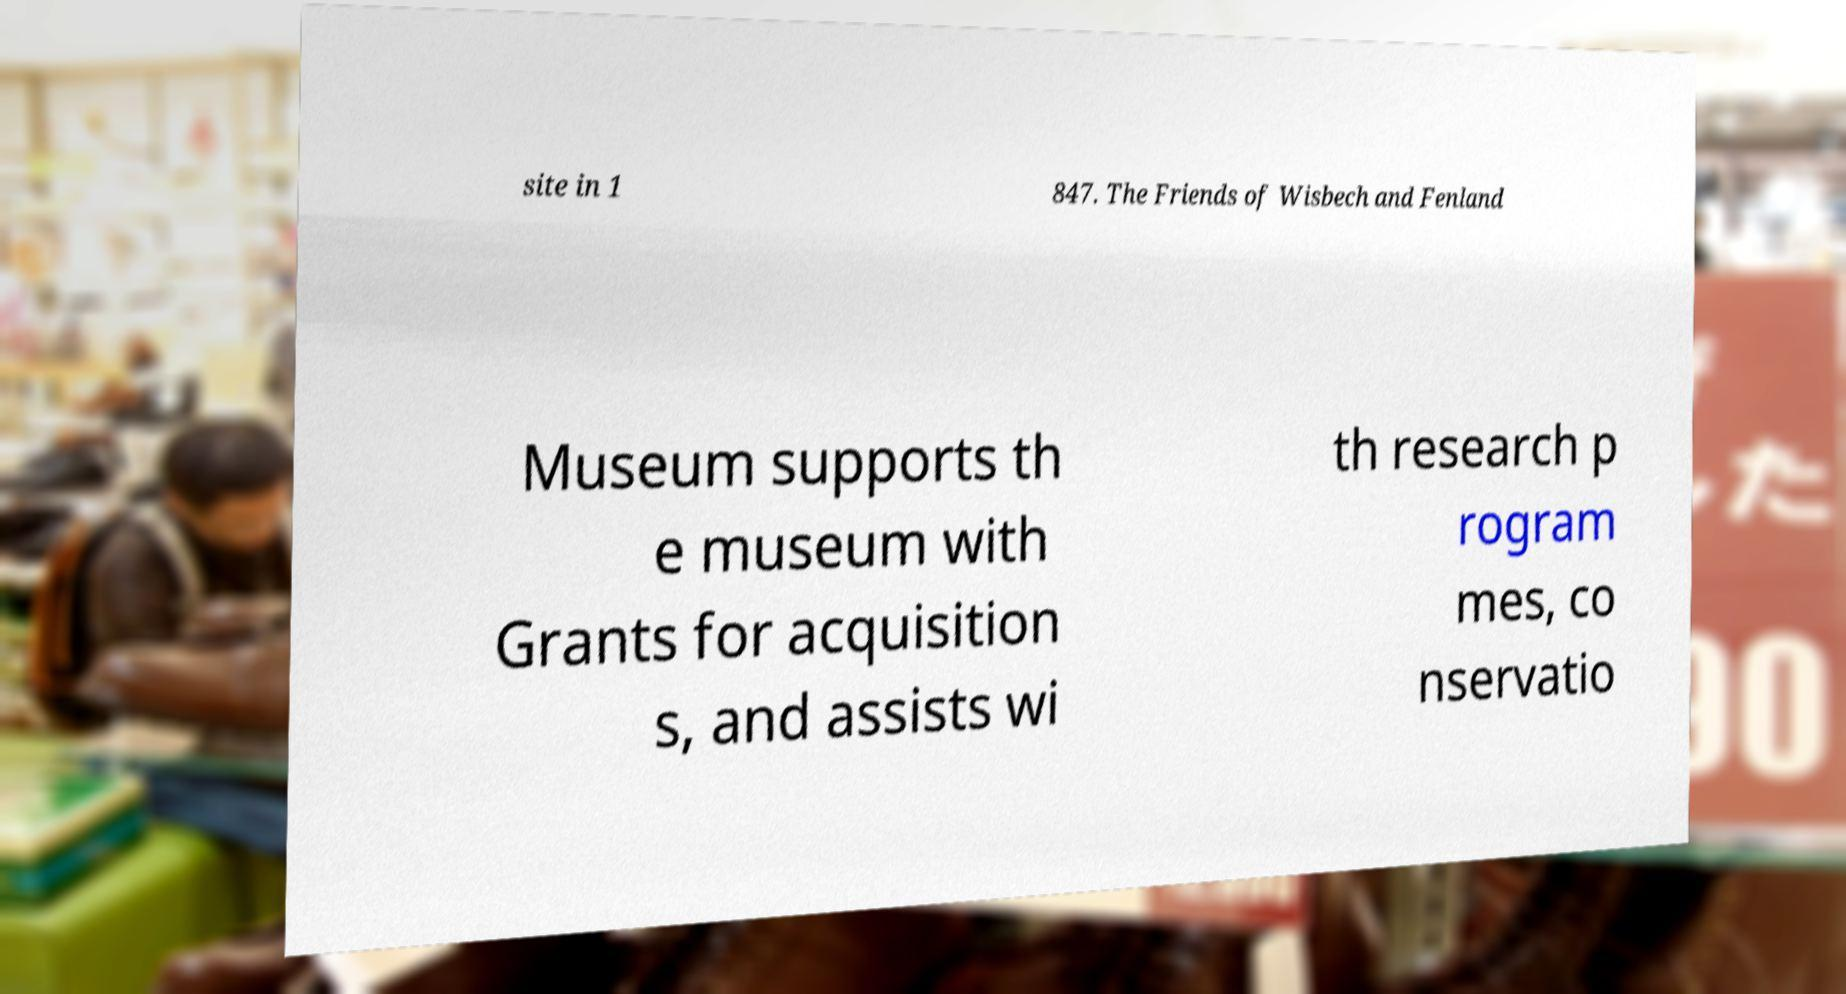Could you extract and type out the text from this image? site in 1 847. The Friends of Wisbech and Fenland Museum supports th e museum with Grants for acquisition s, and assists wi th research p rogram mes, co nservatio 